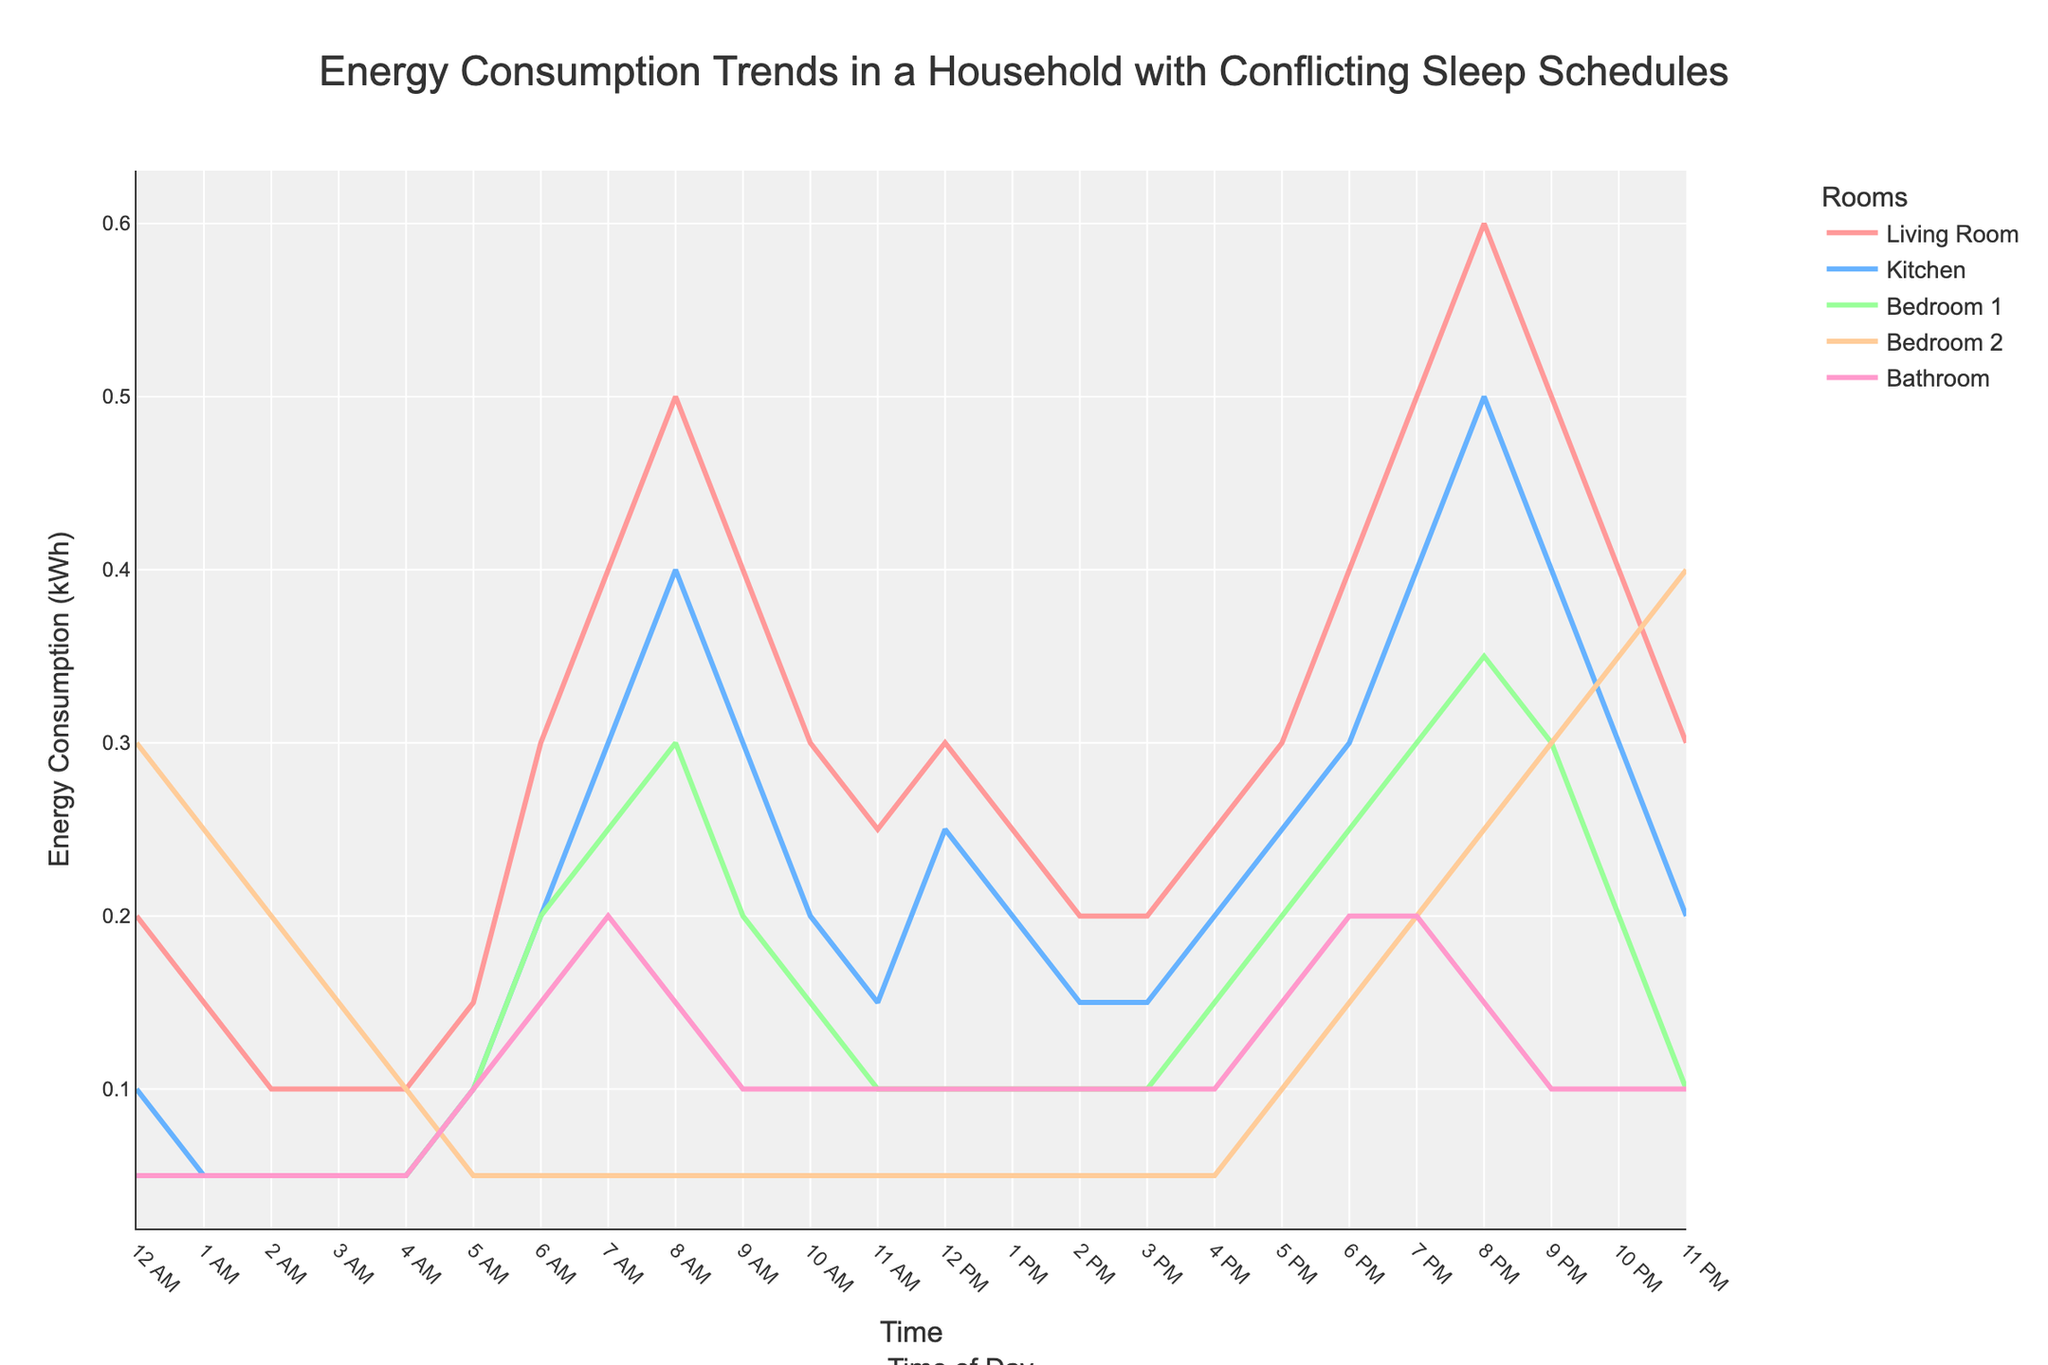What time of day does the Living Room use the most energy? The Living Room's energy consumption is highest when the value reaches its peak on the graph. The highest value for the Living Room is at 8 PM.
Answer: 8 PM How does energy consumption in Bedroom 2 compare between 3 AM and 11 PM? Compare the values of Bedroom 2 at 3 AM and 11 PM. Bedroom 2 consumes 0.15 kWh at 3 AM and 0.4 kWh at 11 PM.
Answer: Higher at 11 PM What is the average energy consumption for the Kitchen between 6 PM and 10 PM? The values for the Kitchen between 6 PM and 10 PM are 0.3, 0.4, 0.5, 0.4, and 0.3 kWh. Summing these gives 1.9, and dividing by the number of data points (5) gives 0.38 kWh.
Answer: 0.38 kWh Which room has the lowest overall energy consumption? Observe the general trend for each room across the entire time span. Bedroom 1 consistently has the lowest values.
Answer: Bedroom 1 Is there a time when the energy consumption in the Bathroom is higher than in the Kitchen? Compare the values of the Bathroom and Kitchen for each time point. There is no time when the Bathroom's energy consumption exceeds the Kitchen's.
Answer: No During which hour does the Living Room's energy consumption drop below its 6 AM value (0.3 kWh) after peaking in the morning? The Living Room's energy consumption peaks at 8 AM (0.5 kWh). It stays above 0.3 kWh until 9 AM when it drops to 0.4 kWh.
Answer: 9 AM How does the energy consumption trend in Bedroom 2 differ from Bedroom 1 between 9 PM and 11 PM? Between 9 PM and 11 PM, Bedroom 2's consumption increases from 0.3 to 0.4 kWh, while Bedroom 1's consumption decreases from 0.3 to 0.1 kWh.
Answer: Bedroom 2 increases, Bedroom 1 decreases What is the total energy consumption for the Living Room and Kitchen combined at 7 PM? Add the values of the Living Room and Kitchen at 7 PM (0.5 kWh for Living Room and 0.4 kWh for Kitchen). The total is 0.5 + 0.4 = 0.9 kWh.
Answer: 0.9 kWh Which room shows a steady decrease in energy consumption from midnight to 4 AM? Examine the energy consumption trends from midnight to 4 AM for each room. Bedroom 2 shows a steady decrease from 0.3 kWh to 0.1 kWh.
Answer: Bedroom 2 